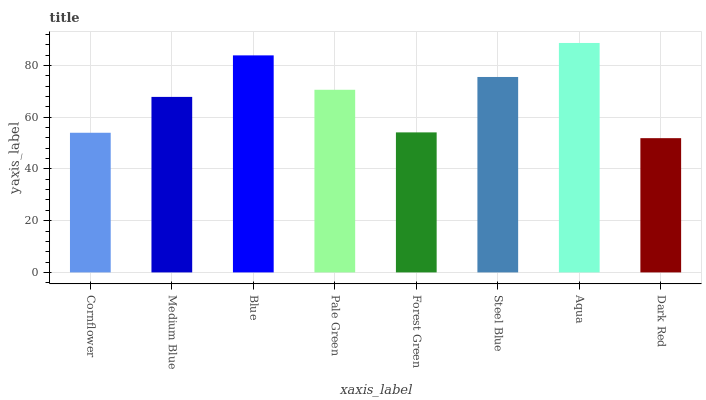Is Dark Red the minimum?
Answer yes or no. Yes. Is Aqua the maximum?
Answer yes or no. Yes. Is Medium Blue the minimum?
Answer yes or no. No. Is Medium Blue the maximum?
Answer yes or no. No. Is Medium Blue greater than Cornflower?
Answer yes or no. Yes. Is Cornflower less than Medium Blue?
Answer yes or no. Yes. Is Cornflower greater than Medium Blue?
Answer yes or no. No. Is Medium Blue less than Cornflower?
Answer yes or no. No. Is Pale Green the high median?
Answer yes or no. Yes. Is Medium Blue the low median?
Answer yes or no. Yes. Is Blue the high median?
Answer yes or no. No. Is Cornflower the low median?
Answer yes or no. No. 